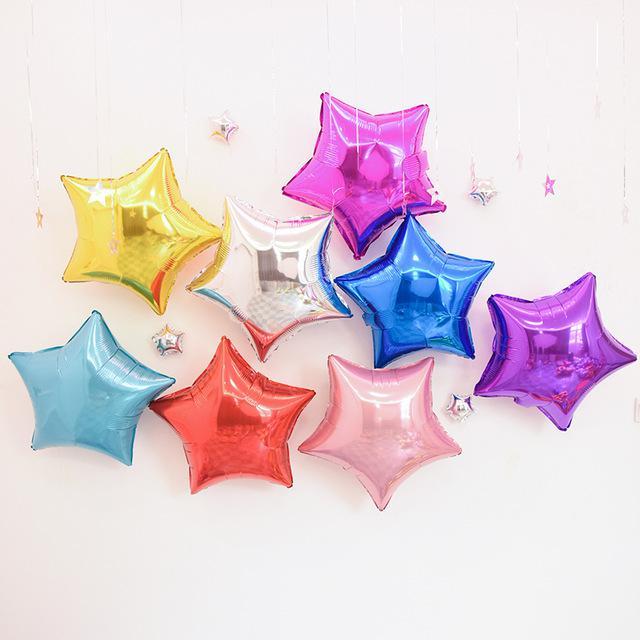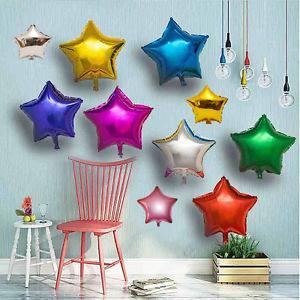The first image is the image on the left, the second image is the image on the right. Analyze the images presented: Is the assertion "IN at least one image there is a single star balloon." valid? Answer yes or no. No. The first image is the image on the left, the second image is the image on the right. Considering the images on both sides, is "Each image includes at least one star-shaped balloon, and at least one image includes multiple colors of star balloons, including gold, green, red, and blue." valid? Answer yes or no. Yes. 